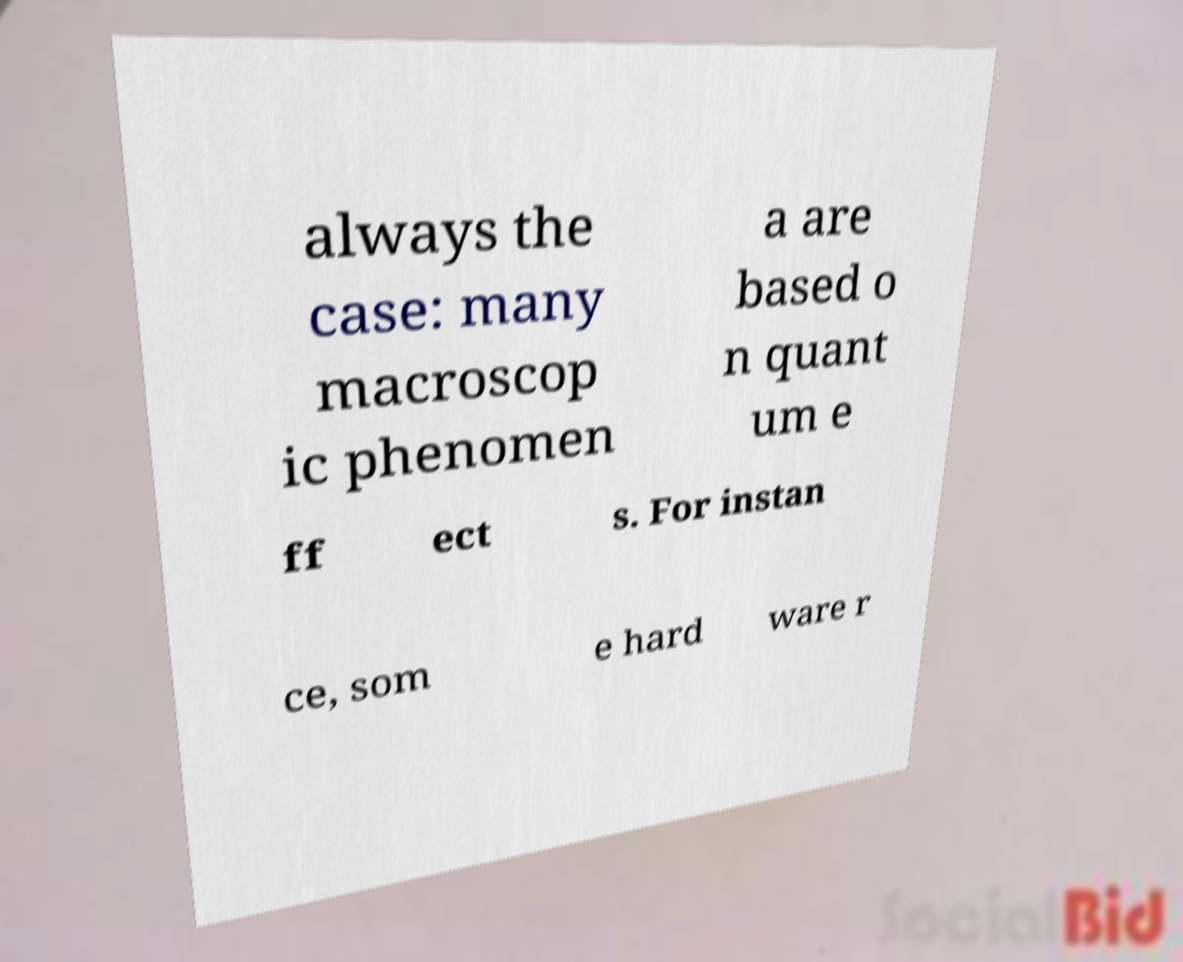For documentation purposes, I need the text within this image transcribed. Could you provide that? always the case: many macroscop ic phenomen a are based o n quant um e ff ect s. For instan ce, som e hard ware r 